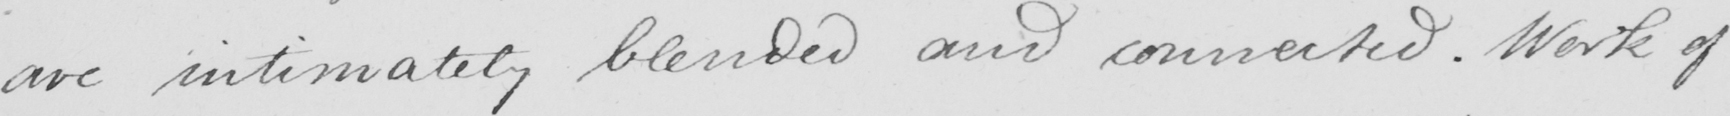Can you tell me what this handwritten text says? are intimately blended and connected . Work of 